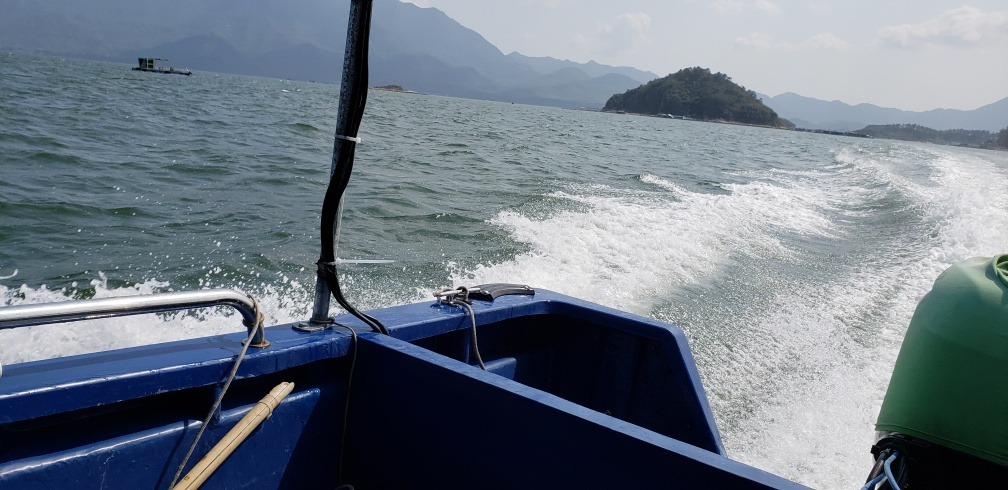Are there any quality issues with this image? While the overall composition and exposure of the image are commendable, it does suffer from some quality issues, such as motion blur apparent in the waves and the lack of sharpness on the horizon. Additionally, the left side of the image is less exposed compared to the right, indicating a slight imbalance in lighting. 